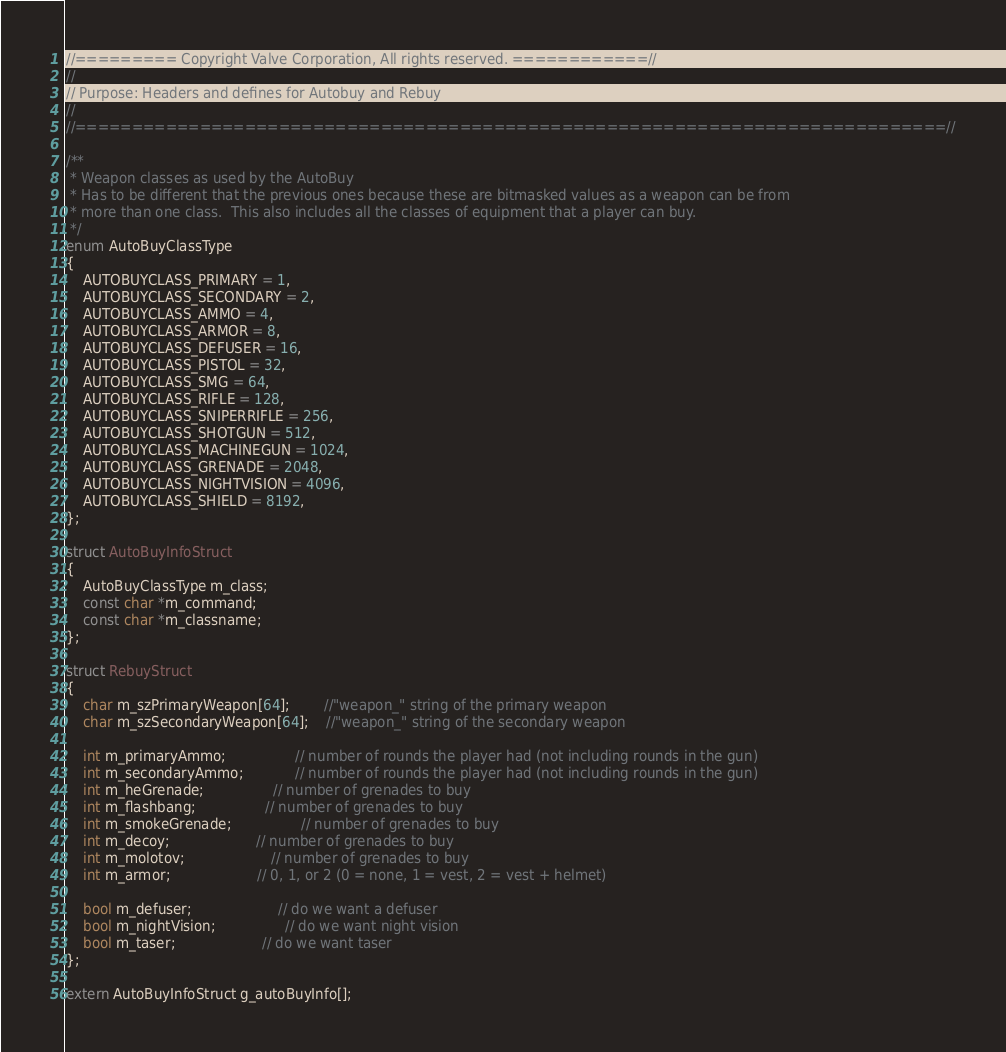Convert code to text. <code><loc_0><loc_0><loc_500><loc_500><_C_>//========= Copyright Valve Corporation, All rights reserved. ============//
//
// Purpose: Headers and defines for Autobuy and Rebuy 
//
//=============================================================================//

/**
 * Weapon classes as used by the AutoBuy
 * Has to be different that the previous ones because these are bitmasked values as a weapon can be from
 * more than one class.  This also includes all the classes of equipment that a player can buy.
 */
enum AutoBuyClassType
{
	AUTOBUYCLASS_PRIMARY = 1,
	AUTOBUYCLASS_SECONDARY = 2,
	AUTOBUYCLASS_AMMO = 4,
	AUTOBUYCLASS_ARMOR = 8,
	AUTOBUYCLASS_DEFUSER = 16,
	AUTOBUYCLASS_PISTOL = 32,
	AUTOBUYCLASS_SMG = 64,
	AUTOBUYCLASS_RIFLE = 128,
	AUTOBUYCLASS_SNIPERRIFLE = 256,
	AUTOBUYCLASS_SHOTGUN = 512,
	AUTOBUYCLASS_MACHINEGUN = 1024,
	AUTOBUYCLASS_GRENADE = 2048,
	AUTOBUYCLASS_NIGHTVISION = 4096,
	AUTOBUYCLASS_SHIELD = 8192,
};

struct AutoBuyInfoStruct
{
	AutoBuyClassType m_class;
	const char *m_command;
	const char *m_classname;
};

struct RebuyStruct
{
	char m_szPrimaryWeapon[64];		//"weapon_" string of the primary weapon
	char m_szSecondaryWeapon[64];	//"weapon_" string of the secondary weapon

	int m_primaryAmmo;				// number of rounds the player had (not including rounds in the gun)
	int m_secondaryAmmo;			// number of rounds the player had (not including rounds in the gun)
	int m_heGrenade;				// number of grenades to buy
	int m_flashbang;				// number of grenades to buy
	int m_smokeGrenade;				// number of grenades to buy
	int m_decoy;					// number of grenades to buy
	int m_molotov;					// number of grenades to buy
	int m_armor;					// 0, 1, or 2 (0 = none, 1 = vest, 2 = vest + helmet)

	bool m_defuser;					// do we want a defuser
	bool m_nightVision;				// do we want night vision
	bool m_taser;					// do we want taser
};

extern AutoBuyInfoStruct g_autoBuyInfo[];
</code> 